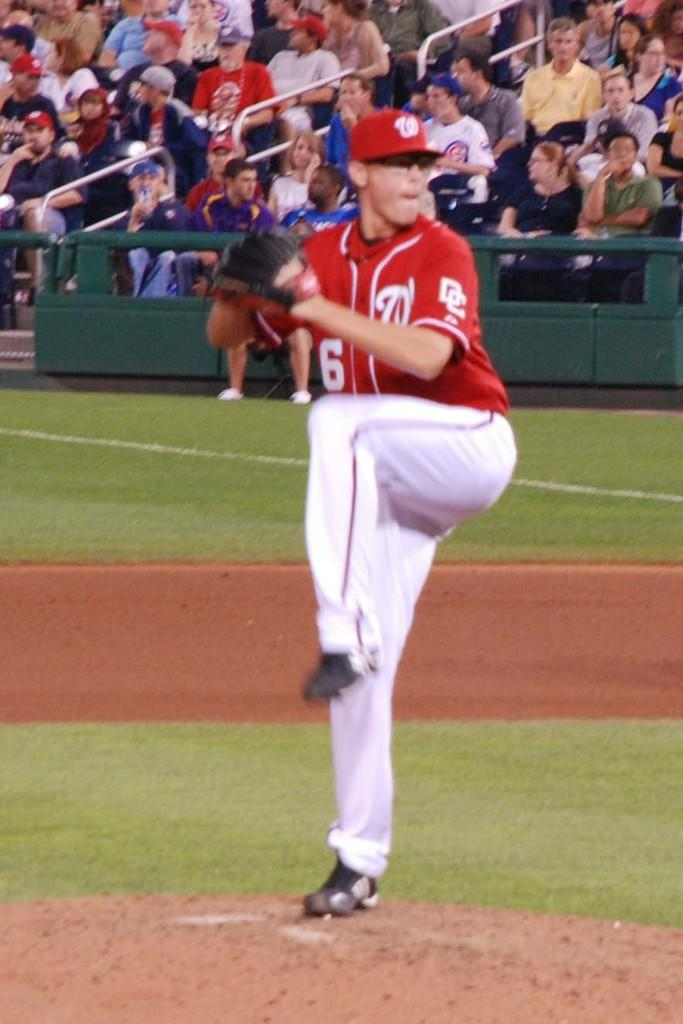<image>
Describe the image concisely. The player wearing number 6 is about to pitch the ball on the field. 